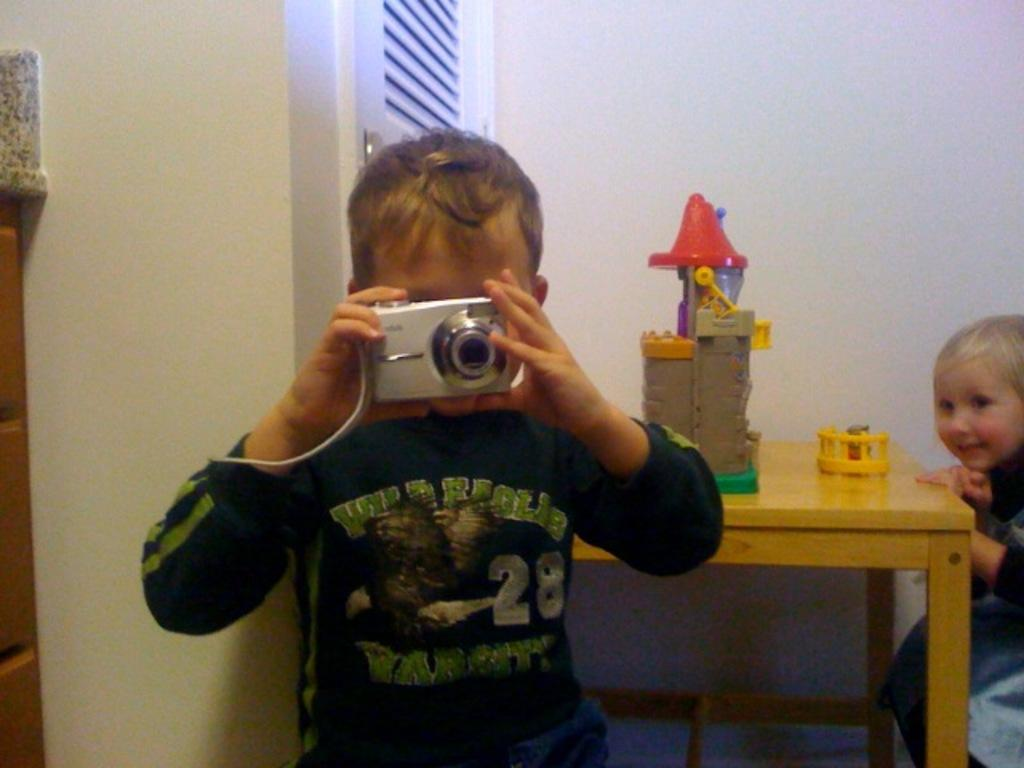What is the person in the image doing? The person is standing in the image and holding a camera in their hand. What else can be seen in the image besides the person with the camera? There is a table in the image, and toys are present on the table. Are there any other people in the image? Yes, there is a person sitting at the right side of the image. What type of battle is taking place in the image? There is no battle present in the image; it features a person holding a camera and a person sitting at a table with toys. Is there a bird visible in the image? There is no bird present in the image. 